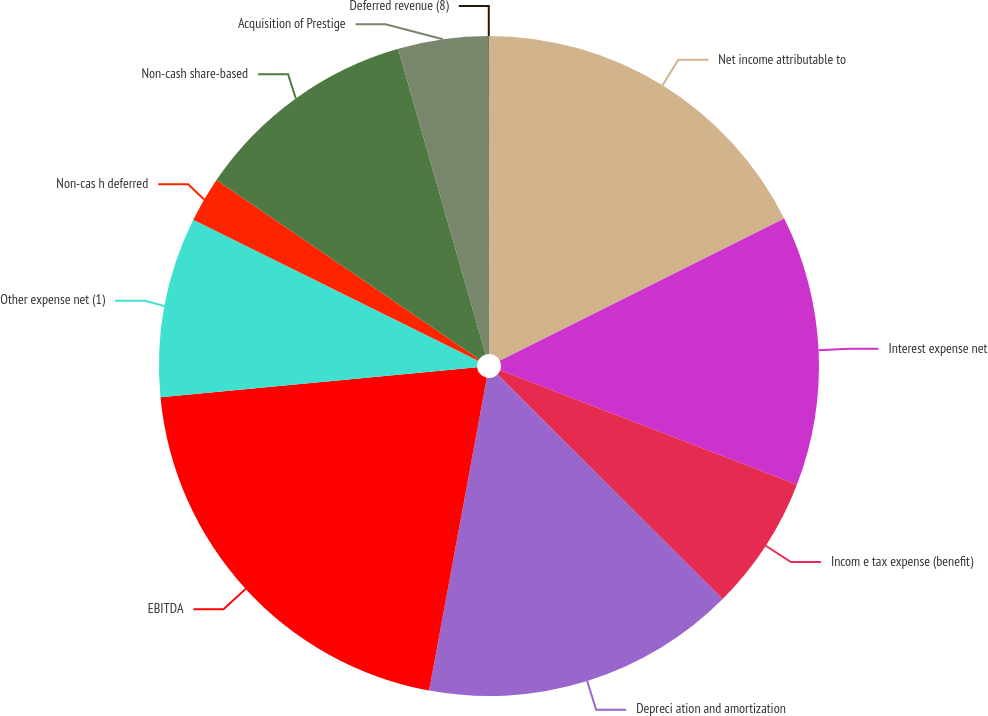Convert chart. <chart><loc_0><loc_0><loc_500><loc_500><pie_chart><fcel>Net income attributable to<fcel>Interest expense net<fcel>Incom e tax expense (benefit)<fcel>Depreci ation and amortization<fcel>EBITDA<fcel>Other expense net (1)<fcel>Non-cas h deferred<fcel>Non-cash share-based<fcel>Acquisition of Prestige<fcel>Deferred revenue (8)<nl><fcel>17.63%<fcel>13.23%<fcel>6.62%<fcel>15.43%<fcel>20.59%<fcel>8.82%<fcel>2.22%<fcel>11.03%<fcel>4.42%<fcel>0.02%<nl></chart> 